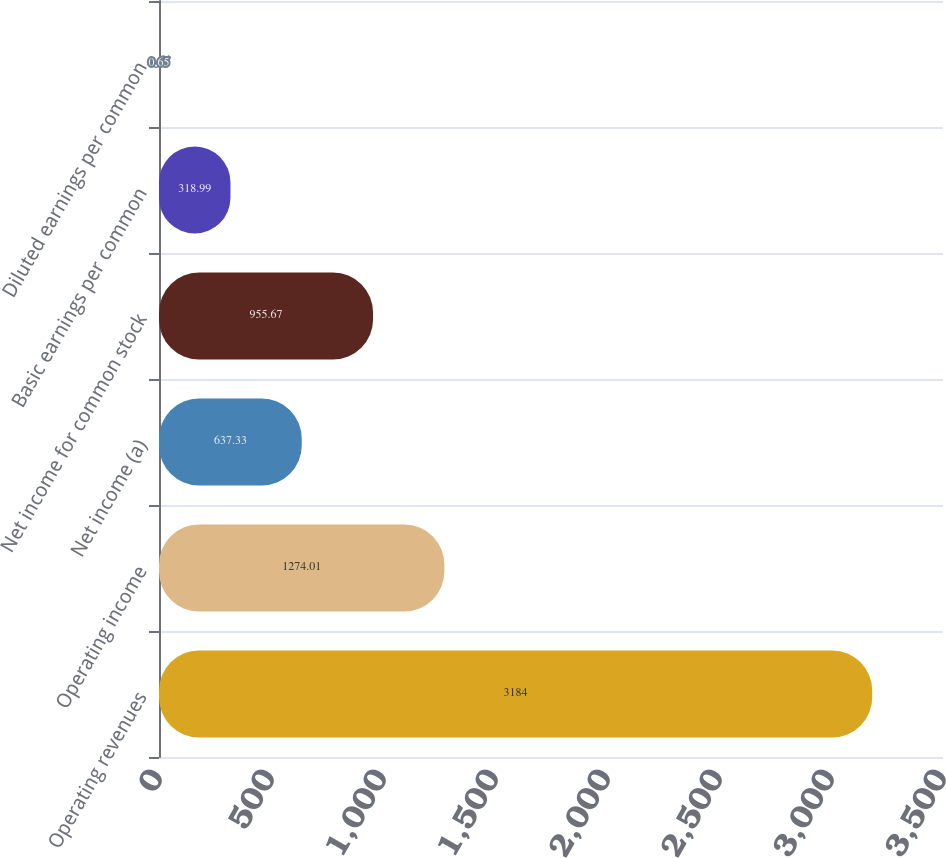Convert chart to OTSL. <chart><loc_0><loc_0><loc_500><loc_500><bar_chart><fcel>Operating revenues<fcel>Operating income<fcel>Net income (a)<fcel>Net income for common stock<fcel>Basic earnings per common<fcel>Diluted earnings per common<nl><fcel>3184<fcel>1274.01<fcel>637.33<fcel>955.67<fcel>318.99<fcel>0.65<nl></chart> 